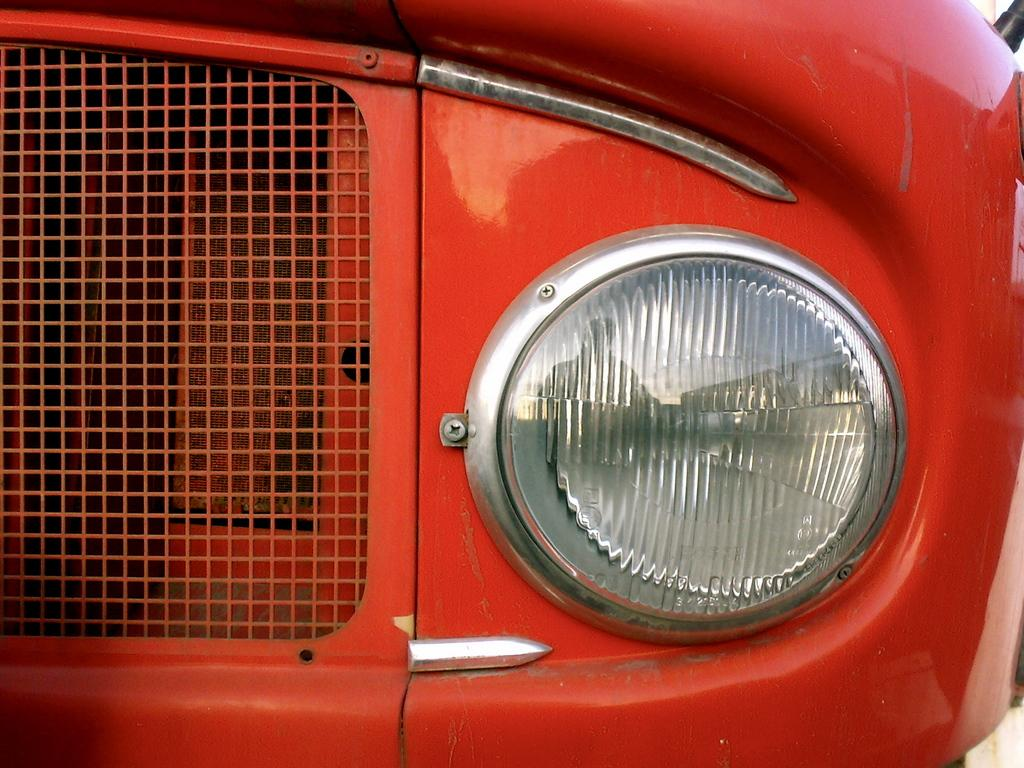What is the main subject in the foreground of the image? There is a vehicle in the foreground of the image. Can you describe the time of day when the image was taken? The image appears to be taken during the day. Reasoning: Let' Let's think step by step in order to produce the conversation. We start by identifying the main subject in the image, which is the vehicle in the foreground. Then, we address the time of day when the image was taken, which is described as during the day. We avoid making any assumptions about the image and stick to the facts provided. Absurd Question/Answer: What type of underwear is the beggar wearing in the image? There is no beggar or underwear present in the image. 